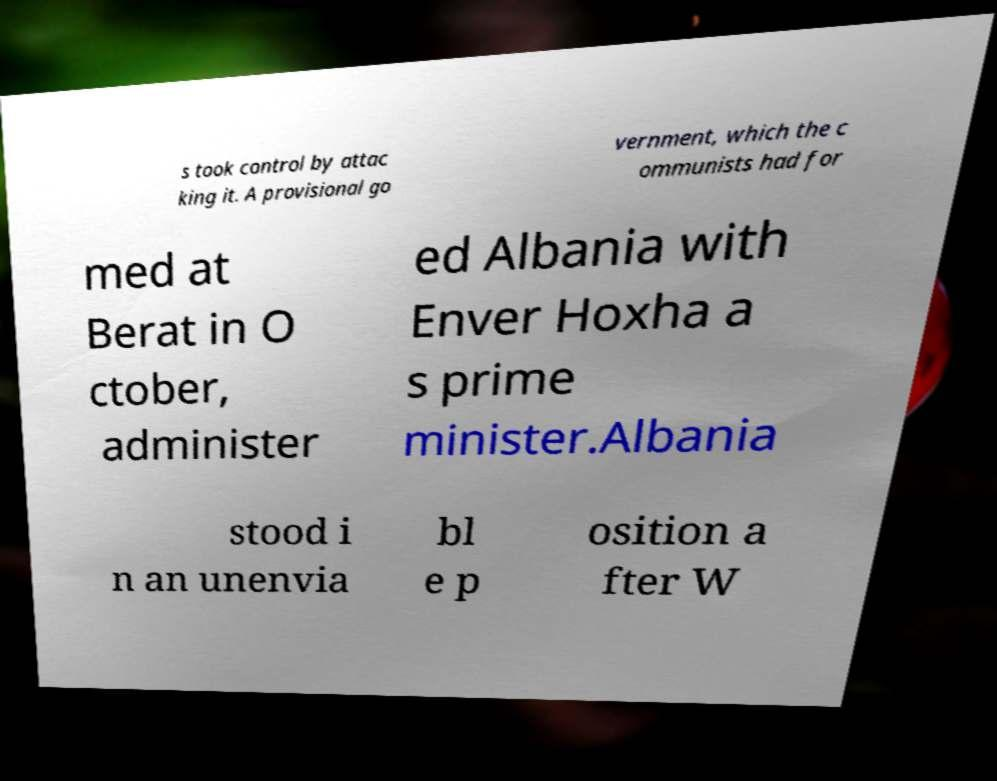Please read and relay the text visible in this image. What does it say? s took control by attac king it. A provisional go vernment, which the c ommunists had for med at Berat in O ctober, administer ed Albania with Enver Hoxha a s prime minister.Albania stood i n an unenvia bl e p osition a fter W 